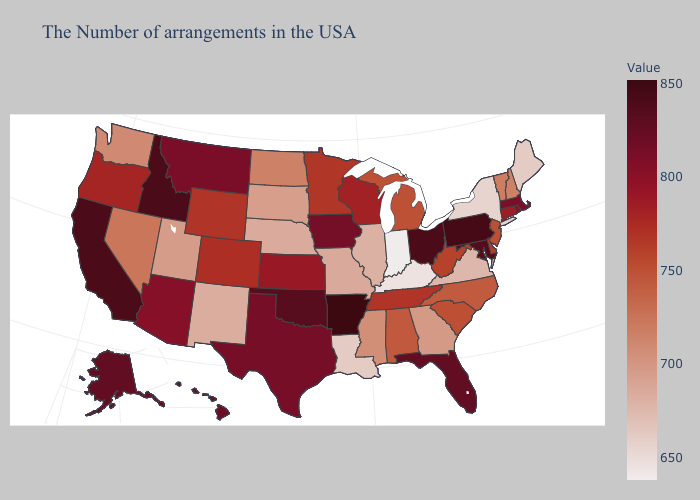Which states have the lowest value in the West?
Write a very short answer. New Mexico. Does Alaska have the highest value in the USA?
Keep it brief. No. Among the states that border Nevada , does Oregon have the lowest value?
Quick response, please. No. Does the map have missing data?
Answer briefly. No. Does Missouri have the lowest value in the MidWest?
Answer briefly. No. Which states have the lowest value in the West?
Give a very brief answer. New Mexico. Does Alaska have a higher value than Virginia?
Keep it brief. Yes. 